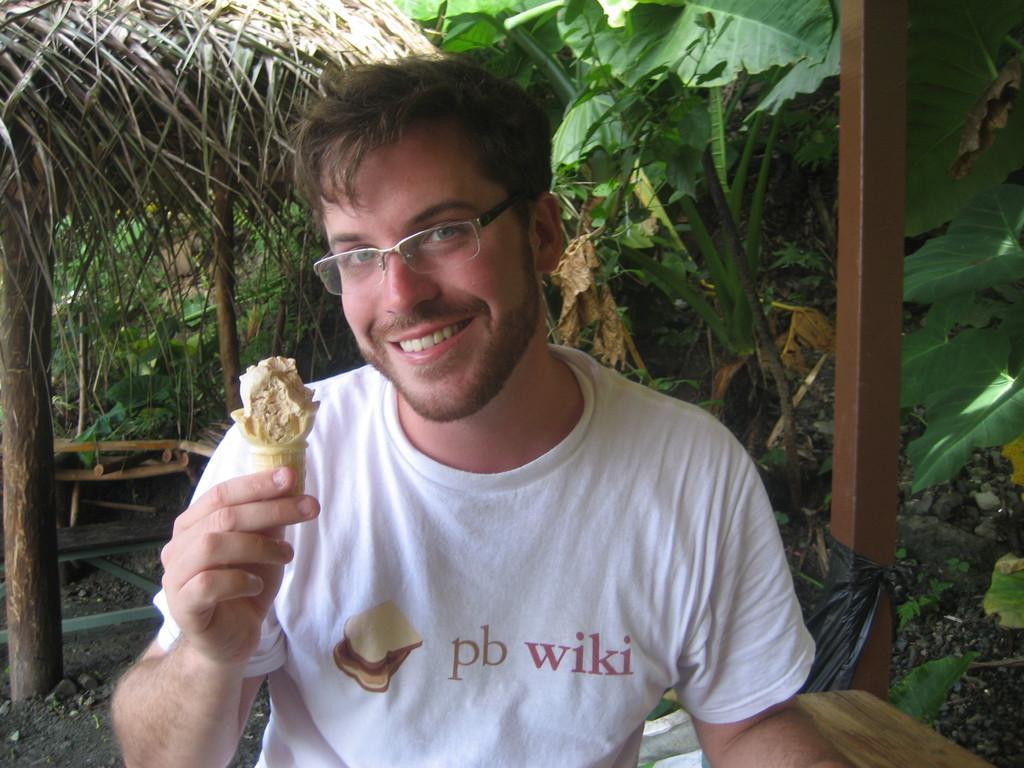In one or two sentences, can you explain what this image depicts? In this image I can see a man and and I can see he is holding an ice cream cone. I can see he is wearing specs, white t shirt and on his t shirt I can see something is written. I can also see smile on his face and in background I can see few trees. 